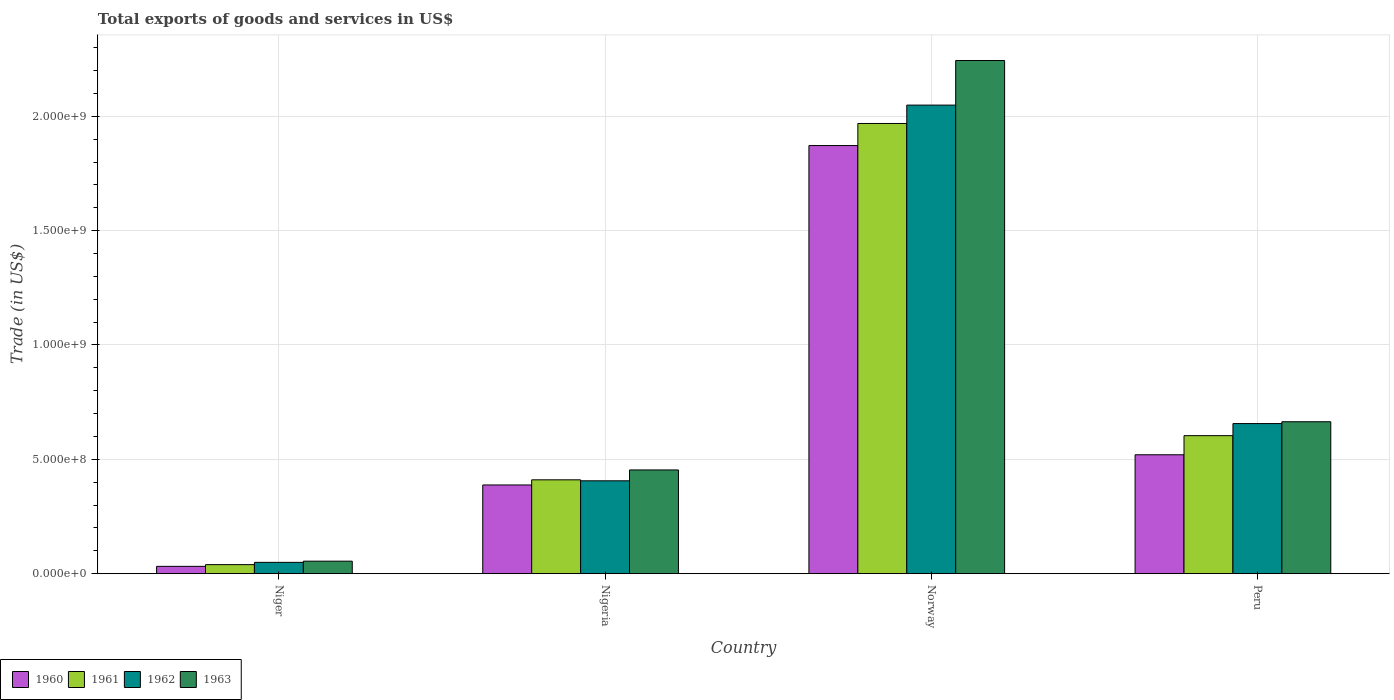How many different coloured bars are there?
Keep it short and to the point. 4. How many groups of bars are there?
Your response must be concise. 4. Are the number of bars on each tick of the X-axis equal?
Keep it short and to the point. Yes. What is the label of the 3rd group of bars from the left?
Offer a very short reply. Norway. What is the total exports of goods and services in 1960 in Niger?
Provide a succinct answer. 3.19e+07. Across all countries, what is the maximum total exports of goods and services in 1962?
Your answer should be very brief. 2.05e+09. Across all countries, what is the minimum total exports of goods and services in 1962?
Keep it short and to the point. 4.94e+07. In which country was the total exports of goods and services in 1960 maximum?
Ensure brevity in your answer.  Norway. In which country was the total exports of goods and services in 1962 minimum?
Ensure brevity in your answer.  Niger. What is the total total exports of goods and services in 1960 in the graph?
Provide a short and direct response. 2.81e+09. What is the difference between the total exports of goods and services in 1963 in Niger and that in Peru?
Offer a very short reply. -6.10e+08. What is the difference between the total exports of goods and services in 1960 in Nigeria and the total exports of goods and services in 1963 in Niger?
Your response must be concise. 3.33e+08. What is the average total exports of goods and services in 1963 per country?
Make the answer very short. 8.54e+08. What is the difference between the total exports of goods and services of/in 1961 and total exports of goods and services of/in 1962 in Norway?
Offer a very short reply. -8.04e+07. What is the ratio of the total exports of goods and services in 1960 in Niger to that in Norway?
Offer a terse response. 0.02. Is the total exports of goods and services in 1961 in Norway less than that in Peru?
Make the answer very short. No. Is the difference between the total exports of goods and services in 1961 in Niger and Norway greater than the difference between the total exports of goods and services in 1962 in Niger and Norway?
Ensure brevity in your answer.  Yes. What is the difference between the highest and the second highest total exports of goods and services in 1960?
Give a very brief answer. -1.48e+09. What is the difference between the highest and the lowest total exports of goods and services in 1961?
Your response must be concise. 1.93e+09. Is the sum of the total exports of goods and services in 1962 in Niger and Norway greater than the maximum total exports of goods and services in 1960 across all countries?
Give a very brief answer. Yes. Is it the case that in every country, the sum of the total exports of goods and services in 1961 and total exports of goods and services in 1960 is greater than the sum of total exports of goods and services in 1962 and total exports of goods and services in 1963?
Offer a very short reply. No. What does the 2nd bar from the left in Niger represents?
Provide a short and direct response. 1961. What does the 3rd bar from the right in Peru represents?
Keep it short and to the point. 1961. Is it the case that in every country, the sum of the total exports of goods and services in 1961 and total exports of goods and services in 1963 is greater than the total exports of goods and services in 1960?
Give a very brief answer. Yes. How many bars are there?
Provide a succinct answer. 16. Are all the bars in the graph horizontal?
Offer a very short reply. No. How many countries are there in the graph?
Provide a short and direct response. 4. What is the difference between two consecutive major ticks on the Y-axis?
Ensure brevity in your answer.  5.00e+08. Does the graph contain grids?
Provide a succinct answer. Yes. How many legend labels are there?
Ensure brevity in your answer.  4. What is the title of the graph?
Your answer should be compact. Total exports of goods and services in US$. Does "2014" appear as one of the legend labels in the graph?
Keep it short and to the point. No. What is the label or title of the Y-axis?
Give a very brief answer. Trade (in US$). What is the Trade (in US$) in 1960 in Niger?
Ensure brevity in your answer.  3.19e+07. What is the Trade (in US$) in 1961 in Niger?
Make the answer very short. 3.95e+07. What is the Trade (in US$) of 1962 in Niger?
Offer a terse response. 4.94e+07. What is the Trade (in US$) in 1963 in Niger?
Your answer should be very brief. 5.46e+07. What is the Trade (in US$) in 1960 in Nigeria?
Give a very brief answer. 3.88e+08. What is the Trade (in US$) in 1961 in Nigeria?
Your answer should be very brief. 4.10e+08. What is the Trade (in US$) of 1962 in Nigeria?
Provide a succinct answer. 4.06e+08. What is the Trade (in US$) in 1963 in Nigeria?
Ensure brevity in your answer.  4.53e+08. What is the Trade (in US$) of 1960 in Norway?
Your response must be concise. 1.87e+09. What is the Trade (in US$) of 1961 in Norway?
Provide a short and direct response. 1.97e+09. What is the Trade (in US$) in 1962 in Norway?
Provide a short and direct response. 2.05e+09. What is the Trade (in US$) in 1963 in Norway?
Your answer should be very brief. 2.24e+09. What is the Trade (in US$) of 1960 in Peru?
Your response must be concise. 5.20e+08. What is the Trade (in US$) of 1961 in Peru?
Give a very brief answer. 6.03e+08. What is the Trade (in US$) of 1962 in Peru?
Your answer should be compact. 6.56e+08. What is the Trade (in US$) in 1963 in Peru?
Make the answer very short. 6.64e+08. Across all countries, what is the maximum Trade (in US$) in 1960?
Give a very brief answer. 1.87e+09. Across all countries, what is the maximum Trade (in US$) of 1961?
Make the answer very short. 1.97e+09. Across all countries, what is the maximum Trade (in US$) in 1962?
Keep it short and to the point. 2.05e+09. Across all countries, what is the maximum Trade (in US$) in 1963?
Your answer should be compact. 2.24e+09. Across all countries, what is the minimum Trade (in US$) of 1960?
Your response must be concise. 3.19e+07. Across all countries, what is the minimum Trade (in US$) of 1961?
Your answer should be compact. 3.95e+07. Across all countries, what is the minimum Trade (in US$) of 1962?
Make the answer very short. 4.94e+07. Across all countries, what is the minimum Trade (in US$) in 1963?
Give a very brief answer. 5.46e+07. What is the total Trade (in US$) in 1960 in the graph?
Provide a succinct answer. 2.81e+09. What is the total Trade (in US$) of 1961 in the graph?
Provide a succinct answer. 3.02e+09. What is the total Trade (in US$) in 1962 in the graph?
Your answer should be very brief. 3.16e+09. What is the total Trade (in US$) in 1963 in the graph?
Offer a very short reply. 3.42e+09. What is the difference between the Trade (in US$) of 1960 in Niger and that in Nigeria?
Offer a very short reply. -3.56e+08. What is the difference between the Trade (in US$) in 1961 in Niger and that in Nigeria?
Give a very brief answer. -3.71e+08. What is the difference between the Trade (in US$) of 1962 in Niger and that in Nigeria?
Ensure brevity in your answer.  -3.57e+08. What is the difference between the Trade (in US$) of 1963 in Niger and that in Nigeria?
Provide a succinct answer. -3.99e+08. What is the difference between the Trade (in US$) of 1960 in Niger and that in Norway?
Provide a succinct answer. -1.84e+09. What is the difference between the Trade (in US$) in 1961 in Niger and that in Norway?
Offer a terse response. -1.93e+09. What is the difference between the Trade (in US$) of 1962 in Niger and that in Norway?
Offer a terse response. -2.00e+09. What is the difference between the Trade (in US$) in 1963 in Niger and that in Norway?
Provide a short and direct response. -2.19e+09. What is the difference between the Trade (in US$) in 1960 in Niger and that in Peru?
Offer a very short reply. -4.88e+08. What is the difference between the Trade (in US$) in 1961 in Niger and that in Peru?
Your answer should be very brief. -5.64e+08. What is the difference between the Trade (in US$) in 1962 in Niger and that in Peru?
Provide a short and direct response. -6.07e+08. What is the difference between the Trade (in US$) in 1963 in Niger and that in Peru?
Your response must be concise. -6.10e+08. What is the difference between the Trade (in US$) in 1960 in Nigeria and that in Norway?
Provide a succinct answer. -1.48e+09. What is the difference between the Trade (in US$) in 1961 in Nigeria and that in Norway?
Your answer should be very brief. -1.56e+09. What is the difference between the Trade (in US$) in 1962 in Nigeria and that in Norway?
Ensure brevity in your answer.  -1.64e+09. What is the difference between the Trade (in US$) of 1963 in Nigeria and that in Norway?
Make the answer very short. -1.79e+09. What is the difference between the Trade (in US$) of 1960 in Nigeria and that in Peru?
Your response must be concise. -1.32e+08. What is the difference between the Trade (in US$) of 1961 in Nigeria and that in Peru?
Offer a very short reply. -1.93e+08. What is the difference between the Trade (in US$) in 1962 in Nigeria and that in Peru?
Offer a terse response. -2.50e+08. What is the difference between the Trade (in US$) of 1963 in Nigeria and that in Peru?
Your answer should be very brief. -2.11e+08. What is the difference between the Trade (in US$) of 1960 in Norway and that in Peru?
Your answer should be very brief. 1.35e+09. What is the difference between the Trade (in US$) of 1961 in Norway and that in Peru?
Provide a short and direct response. 1.37e+09. What is the difference between the Trade (in US$) in 1962 in Norway and that in Peru?
Ensure brevity in your answer.  1.39e+09. What is the difference between the Trade (in US$) of 1963 in Norway and that in Peru?
Your answer should be very brief. 1.58e+09. What is the difference between the Trade (in US$) in 1960 in Niger and the Trade (in US$) in 1961 in Nigeria?
Your answer should be very brief. -3.78e+08. What is the difference between the Trade (in US$) of 1960 in Niger and the Trade (in US$) of 1962 in Nigeria?
Give a very brief answer. -3.74e+08. What is the difference between the Trade (in US$) of 1960 in Niger and the Trade (in US$) of 1963 in Nigeria?
Your answer should be very brief. -4.22e+08. What is the difference between the Trade (in US$) in 1961 in Niger and the Trade (in US$) in 1962 in Nigeria?
Make the answer very short. -3.67e+08. What is the difference between the Trade (in US$) of 1961 in Niger and the Trade (in US$) of 1963 in Nigeria?
Give a very brief answer. -4.14e+08. What is the difference between the Trade (in US$) in 1962 in Niger and the Trade (in US$) in 1963 in Nigeria?
Your answer should be compact. -4.04e+08. What is the difference between the Trade (in US$) of 1960 in Niger and the Trade (in US$) of 1961 in Norway?
Offer a very short reply. -1.94e+09. What is the difference between the Trade (in US$) of 1960 in Niger and the Trade (in US$) of 1962 in Norway?
Offer a terse response. -2.02e+09. What is the difference between the Trade (in US$) in 1960 in Niger and the Trade (in US$) in 1963 in Norway?
Make the answer very short. -2.21e+09. What is the difference between the Trade (in US$) in 1961 in Niger and the Trade (in US$) in 1962 in Norway?
Your response must be concise. -2.01e+09. What is the difference between the Trade (in US$) of 1961 in Niger and the Trade (in US$) of 1963 in Norway?
Your response must be concise. -2.20e+09. What is the difference between the Trade (in US$) of 1962 in Niger and the Trade (in US$) of 1963 in Norway?
Provide a succinct answer. -2.19e+09. What is the difference between the Trade (in US$) of 1960 in Niger and the Trade (in US$) of 1961 in Peru?
Your answer should be very brief. -5.71e+08. What is the difference between the Trade (in US$) of 1960 in Niger and the Trade (in US$) of 1962 in Peru?
Offer a very short reply. -6.24e+08. What is the difference between the Trade (in US$) in 1960 in Niger and the Trade (in US$) in 1963 in Peru?
Your response must be concise. -6.32e+08. What is the difference between the Trade (in US$) in 1961 in Niger and the Trade (in US$) in 1962 in Peru?
Your answer should be compact. -6.17e+08. What is the difference between the Trade (in US$) in 1961 in Niger and the Trade (in US$) in 1963 in Peru?
Ensure brevity in your answer.  -6.25e+08. What is the difference between the Trade (in US$) of 1962 in Niger and the Trade (in US$) of 1963 in Peru?
Your answer should be compact. -6.15e+08. What is the difference between the Trade (in US$) in 1960 in Nigeria and the Trade (in US$) in 1961 in Norway?
Offer a very short reply. -1.58e+09. What is the difference between the Trade (in US$) in 1960 in Nigeria and the Trade (in US$) in 1962 in Norway?
Offer a terse response. -1.66e+09. What is the difference between the Trade (in US$) in 1960 in Nigeria and the Trade (in US$) in 1963 in Norway?
Ensure brevity in your answer.  -1.86e+09. What is the difference between the Trade (in US$) in 1961 in Nigeria and the Trade (in US$) in 1962 in Norway?
Ensure brevity in your answer.  -1.64e+09. What is the difference between the Trade (in US$) in 1961 in Nigeria and the Trade (in US$) in 1963 in Norway?
Make the answer very short. -1.83e+09. What is the difference between the Trade (in US$) in 1962 in Nigeria and the Trade (in US$) in 1963 in Norway?
Make the answer very short. -1.84e+09. What is the difference between the Trade (in US$) in 1960 in Nigeria and the Trade (in US$) in 1961 in Peru?
Make the answer very short. -2.16e+08. What is the difference between the Trade (in US$) in 1960 in Nigeria and the Trade (in US$) in 1962 in Peru?
Ensure brevity in your answer.  -2.68e+08. What is the difference between the Trade (in US$) in 1960 in Nigeria and the Trade (in US$) in 1963 in Peru?
Your response must be concise. -2.76e+08. What is the difference between the Trade (in US$) of 1961 in Nigeria and the Trade (in US$) of 1962 in Peru?
Your answer should be very brief. -2.46e+08. What is the difference between the Trade (in US$) of 1961 in Nigeria and the Trade (in US$) of 1963 in Peru?
Offer a very short reply. -2.54e+08. What is the difference between the Trade (in US$) in 1962 in Nigeria and the Trade (in US$) in 1963 in Peru?
Offer a very short reply. -2.58e+08. What is the difference between the Trade (in US$) of 1960 in Norway and the Trade (in US$) of 1961 in Peru?
Give a very brief answer. 1.27e+09. What is the difference between the Trade (in US$) in 1960 in Norway and the Trade (in US$) in 1962 in Peru?
Ensure brevity in your answer.  1.22e+09. What is the difference between the Trade (in US$) of 1960 in Norway and the Trade (in US$) of 1963 in Peru?
Provide a succinct answer. 1.21e+09. What is the difference between the Trade (in US$) in 1961 in Norway and the Trade (in US$) in 1962 in Peru?
Your answer should be very brief. 1.31e+09. What is the difference between the Trade (in US$) of 1961 in Norway and the Trade (in US$) of 1963 in Peru?
Give a very brief answer. 1.30e+09. What is the difference between the Trade (in US$) in 1962 in Norway and the Trade (in US$) in 1963 in Peru?
Ensure brevity in your answer.  1.38e+09. What is the average Trade (in US$) in 1960 per country?
Provide a short and direct response. 7.03e+08. What is the average Trade (in US$) of 1961 per country?
Ensure brevity in your answer.  7.55e+08. What is the average Trade (in US$) of 1962 per country?
Your answer should be very brief. 7.90e+08. What is the average Trade (in US$) of 1963 per country?
Ensure brevity in your answer.  8.54e+08. What is the difference between the Trade (in US$) of 1960 and Trade (in US$) of 1961 in Niger?
Give a very brief answer. -7.53e+06. What is the difference between the Trade (in US$) in 1960 and Trade (in US$) in 1962 in Niger?
Ensure brevity in your answer.  -1.74e+07. What is the difference between the Trade (in US$) in 1960 and Trade (in US$) in 1963 in Niger?
Make the answer very short. -2.27e+07. What is the difference between the Trade (in US$) in 1961 and Trade (in US$) in 1962 in Niger?
Your answer should be compact. -9.91e+06. What is the difference between the Trade (in US$) in 1961 and Trade (in US$) in 1963 in Niger?
Your answer should be very brief. -1.51e+07. What is the difference between the Trade (in US$) of 1962 and Trade (in US$) of 1963 in Niger?
Offer a terse response. -5.23e+06. What is the difference between the Trade (in US$) of 1960 and Trade (in US$) of 1961 in Nigeria?
Your answer should be very brief. -2.25e+07. What is the difference between the Trade (in US$) in 1960 and Trade (in US$) in 1962 in Nigeria?
Make the answer very short. -1.82e+07. What is the difference between the Trade (in US$) of 1960 and Trade (in US$) of 1963 in Nigeria?
Offer a terse response. -6.57e+07. What is the difference between the Trade (in US$) in 1961 and Trade (in US$) in 1962 in Nigeria?
Provide a succinct answer. 4.36e+06. What is the difference between the Trade (in US$) in 1961 and Trade (in US$) in 1963 in Nigeria?
Offer a very short reply. -4.32e+07. What is the difference between the Trade (in US$) of 1962 and Trade (in US$) of 1963 in Nigeria?
Your answer should be compact. -4.75e+07. What is the difference between the Trade (in US$) of 1960 and Trade (in US$) of 1961 in Norway?
Your answer should be compact. -9.65e+07. What is the difference between the Trade (in US$) in 1960 and Trade (in US$) in 1962 in Norway?
Make the answer very short. -1.77e+08. What is the difference between the Trade (in US$) of 1960 and Trade (in US$) of 1963 in Norway?
Offer a terse response. -3.72e+08. What is the difference between the Trade (in US$) in 1961 and Trade (in US$) in 1962 in Norway?
Offer a terse response. -8.04e+07. What is the difference between the Trade (in US$) in 1961 and Trade (in US$) in 1963 in Norway?
Offer a terse response. -2.75e+08. What is the difference between the Trade (in US$) in 1962 and Trade (in US$) in 1963 in Norway?
Keep it short and to the point. -1.95e+08. What is the difference between the Trade (in US$) of 1960 and Trade (in US$) of 1961 in Peru?
Your answer should be very brief. -8.36e+07. What is the difference between the Trade (in US$) in 1960 and Trade (in US$) in 1962 in Peru?
Give a very brief answer. -1.36e+08. What is the difference between the Trade (in US$) in 1960 and Trade (in US$) in 1963 in Peru?
Provide a short and direct response. -1.44e+08. What is the difference between the Trade (in US$) of 1961 and Trade (in US$) of 1962 in Peru?
Give a very brief answer. -5.29e+07. What is the difference between the Trade (in US$) of 1961 and Trade (in US$) of 1963 in Peru?
Make the answer very short. -6.09e+07. What is the difference between the Trade (in US$) of 1962 and Trade (in US$) of 1963 in Peru?
Your response must be concise. -8.02e+06. What is the ratio of the Trade (in US$) of 1960 in Niger to that in Nigeria?
Keep it short and to the point. 0.08. What is the ratio of the Trade (in US$) of 1961 in Niger to that in Nigeria?
Make the answer very short. 0.1. What is the ratio of the Trade (in US$) in 1962 in Niger to that in Nigeria?
Provide a succinct answer. 0.12. What is the ratio of the Trade (in US$) in 1963 in Niger to that in Nigeria?
Your answer should be compact. 0.12. What is the ratio of the Trade (in US$) of 1960 in Niger to that in Norway?
Provide a short and direct response. 0.02. What is the ratio of the Trade (in US$) of 1961 in Niger to that in Norway?
Ensure brevity in your answer.  0.02. What is the ratio of the Trade (in US$) of 1962 in Niger to that in Norway?
Give a very brief answer. 0.02. What is the ratio of the Trade (in US$) of 1963 in Niger to that in Norway?
Make the answer very short. 0.02. What is the ratio of the Trade (in US$) of 1960 in Niger to that in Peru?
Your answer should be compact. 0.06. What is the ratio of the Trade (in US$) of 1961 in Niger to that in Peru?
Provide a short and direct response. 0.07. What is the ratio of the Trade (in US$) in 1962 in Niger to that in Peru?
Keep it short and to the point. 0.08. What is the ratio of the Trade (in US$) of 1963 in Niger to that in Peru?
Your response must be concise. 0.08. What is the ratio of the Trade (in US$) in 1960 in Nigeria to that in Norway?
Your response must be concise. 0.21. What is the ratio of the Trade (in US$) in 1961 in Nigeria to that in Norway?
Make the answer very short. 0.21. What is the ratio of the Trade (in US$) in 1962 in Nigeria to that in Norway?
Keep it short and to the point. 0.2. What is the ratio of the Trade (in US$) of 1963 in Nigeria to that in Norway?
Provide a succinct answer. 0.2. What is the ratio of the Trade (in US$) in 1960 in Nigeria to that in Peru?
Provide a short and direct response. 0.75. What is the ratio of the Trade (in US$) of 1961 in Nigeria to that in Peru?
Give a very brief answer. 0.68. What is the ratio of the Trade (in US$) of 1962 in Nigeria to that in Peru?
Provide a short and direct response. 0.62. What is the ratio of the Trade (in US$) of 1963 in Nigeria to that in Peru?
Make the answer very short. 0.68. What is the ratio of the Trade (in US$) in 1960 in Norway to that in Peru?
Give a very brief answer. 3.6. What is the ratio of the Trade (in US$) of 1961 in Norway to that in Peru?
Give a very brief answer. 3.26. What is the ratio of the Trade (in US$) of 1962 in Norway to that in Peru?
Keep it short and to the point. 3.12. What is the ratio of the Trade (in US$) of 1963 in Norway to that in Peru?
Offer a very short reply. 3.38. What is the difference between the highest and the second highest Trade (in US$) of 1960?
Your answer should be compact. 1.35e+09. What is the difference between the highest and the second highest Trade (in US$) in 1961?
Give a very brief answer. 1.37e+09. What is the difference between the highest and the second highest Trade (in US$) in 1962?
Ensure brevity in your answer.  1.39e+09. What is the difference between the highest and the second highest Trade (in US$) in 1963?
Your answer should be compact. 1.58e+09. What is the difference between the highest and the lowest Trade (in US$) in 1960?
Your answer should be very brief. 1.84e+09. What is the difference between the highest and the lowest Trade (in US$) of 1961?
Make the answer very short. 1.93e+09. What is the difference between the highest and the lowest Trade (in US$) of 1962?
Offer a terse response. 2.00e+09. What is the difference between the highest and the lowest Trade (in US$) of 1963?
Ensure brevity in your answer.  2.19e+09. 